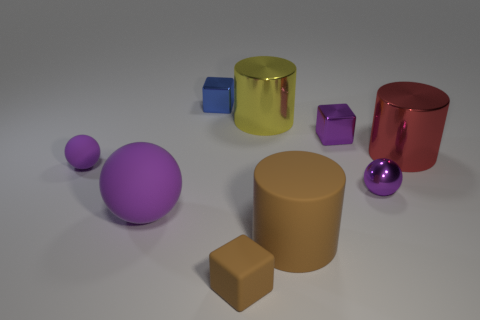Subtract all rubber balls. How many balls are left? 1 Subtract all yellow cylinders. How many cylinders are left? 2 Subtract 0 brown spheres. How many objects are left? 9 Subtract all blocks. How many objects are left? 6 Subtract all green balls. Subtract all red cylinders. How many balls are left? 3 Subtract all brown cubes. How many green spheres are left? 0 Subtract all small purple things. Subtract all brown blocks. How many objects are left? 5 Add 1 purple metallic cubes. How many purple metallic cubes are left? 2 Add 7 purple cubes. How many purple cubes exist? 8 